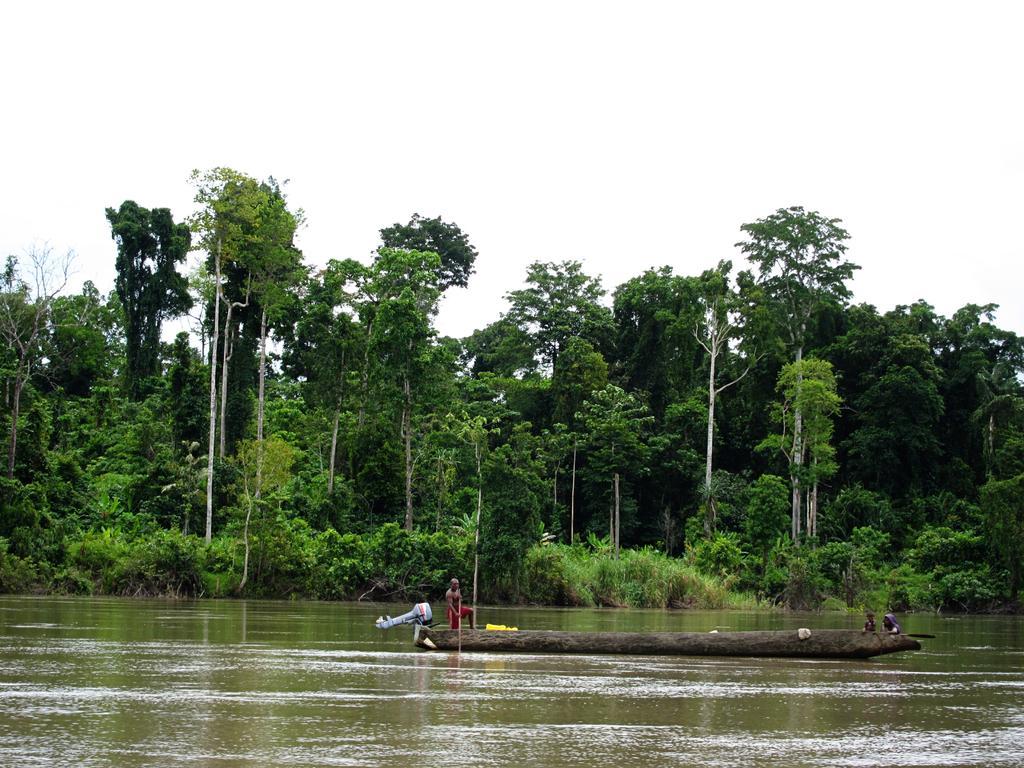In one or two sentences, can you explain what this image depicts? In this image I can see the lake in the middle in which I can see a boat, on the top of boat I can see persons, beside the lake there are trees, bushes, plants visible, at the top there is the sky visible. 